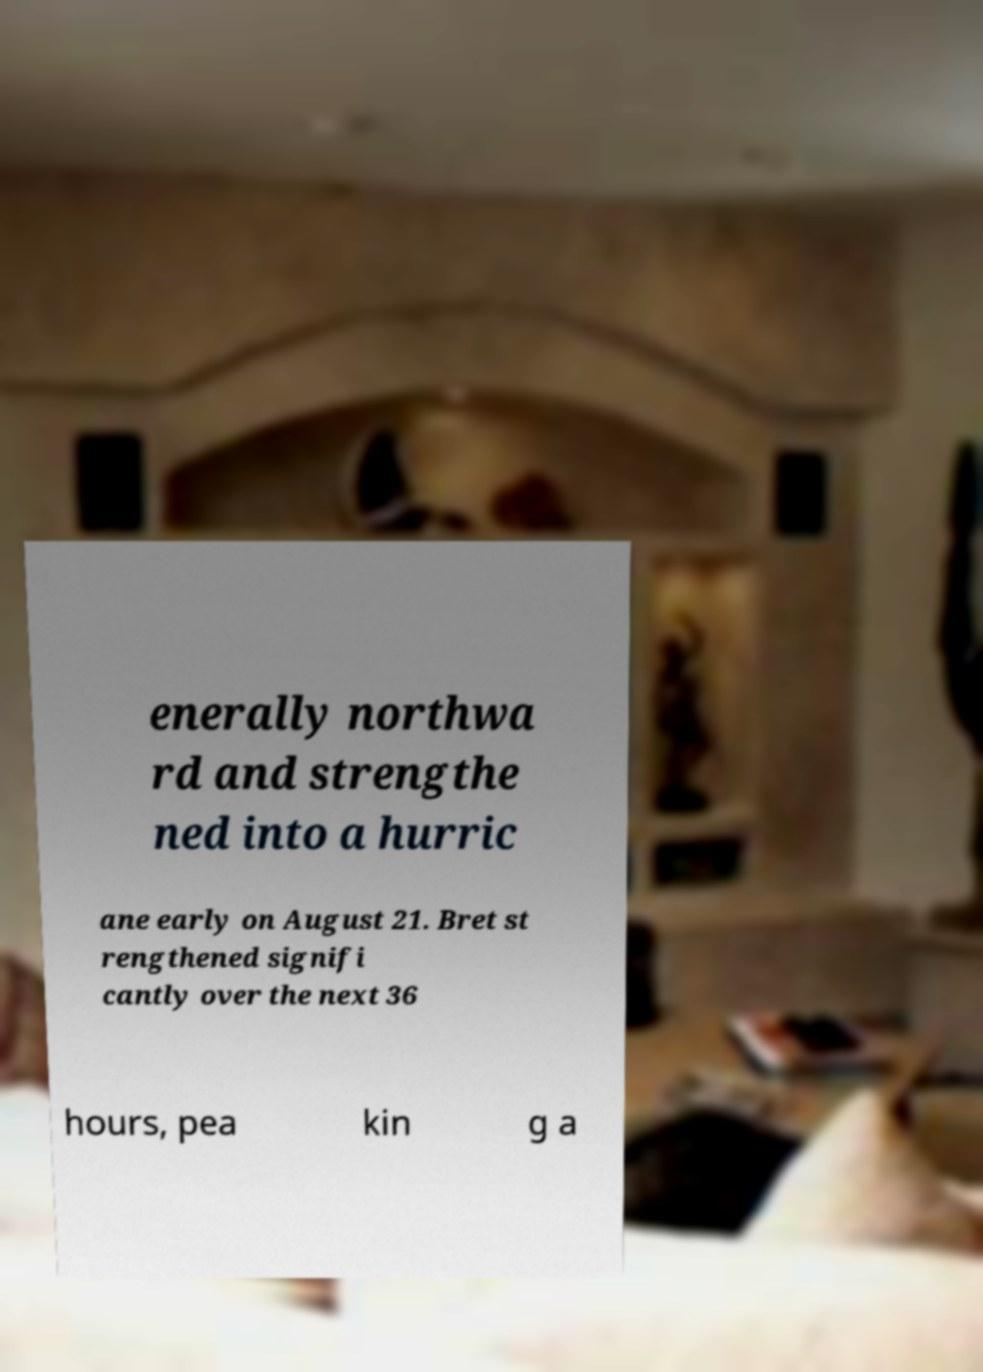Please read and relay the text visible in this image. What does it say? enerally northwa rd and strengthe ned into a hurric ane early on August 21. Bret st rengthened signifi cantly over the next 36 hours, pea kin g a 